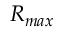<formula> <loc_0><loc_0><loc_500><loc_500>R _ { \max }</formula> 